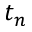Convert formula to latex. <formula><loc_0><loc_0><loc_500><loc_500>t _ { n }</formula> 